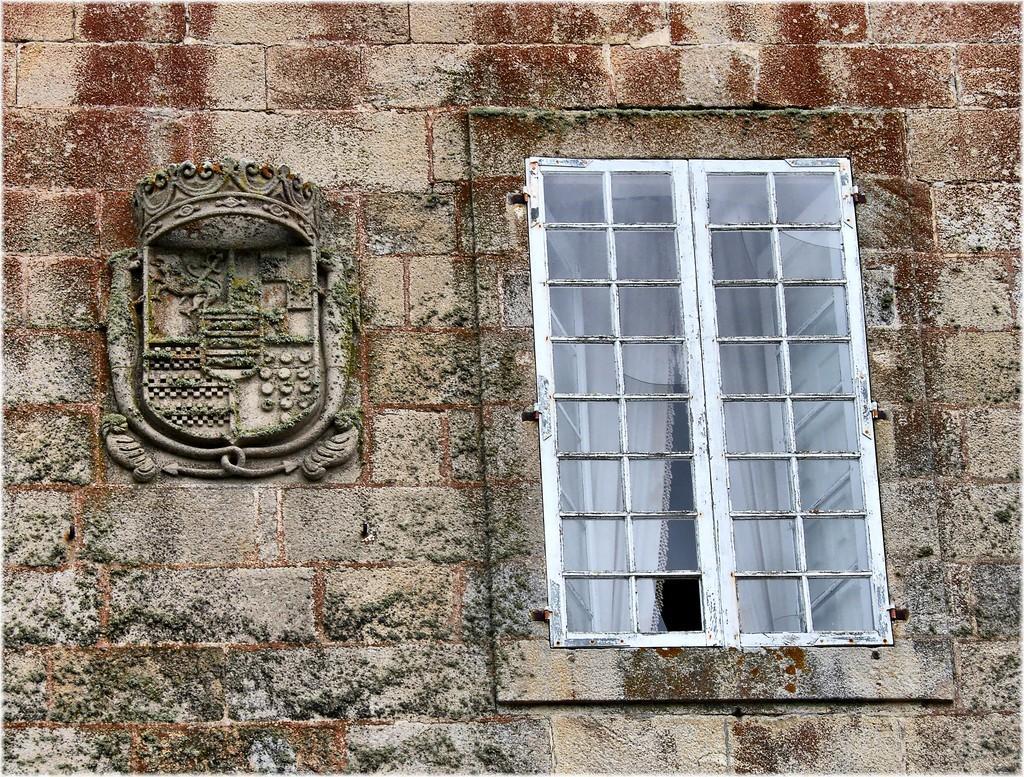How would you summarize this image in a sentence or two? In this picture we can see a window, curtains and a sculpture on the wall. 